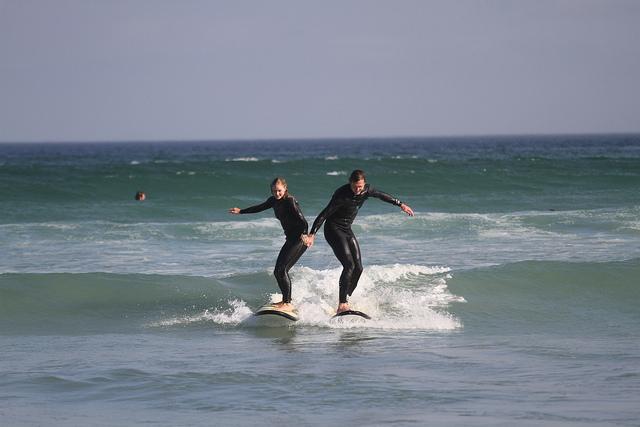Is it a hot day?
Give a very brief answer. Yes. How many women are surfing?
Answer briefly. 1. Do these people know each other?
Answer briefly. Yes. Does guys have on swim trunks?
Give a very brief answer. No. Are there three people in the photo?
Concise answer only. Yes. What color are the wetsuits?
Give a very brief answer. Black. 